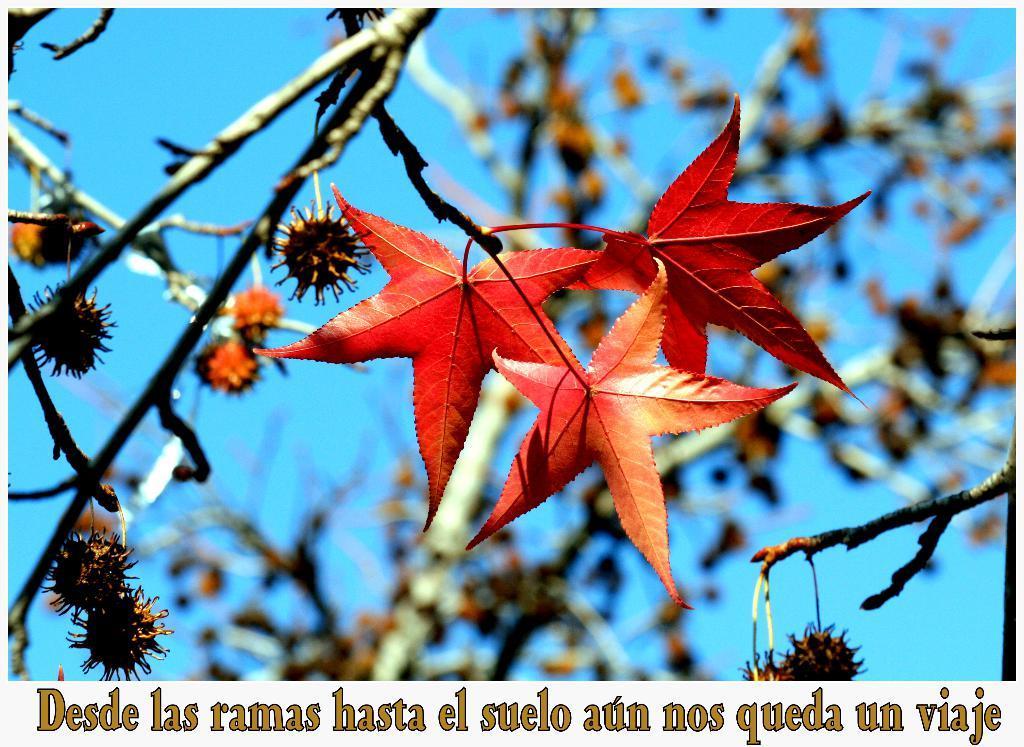Could you give a brief overview of what you see in this image? In this image we can see some leaves on the branches of a tree. In the background, we can see the sky. At the bottom we can see some text. 